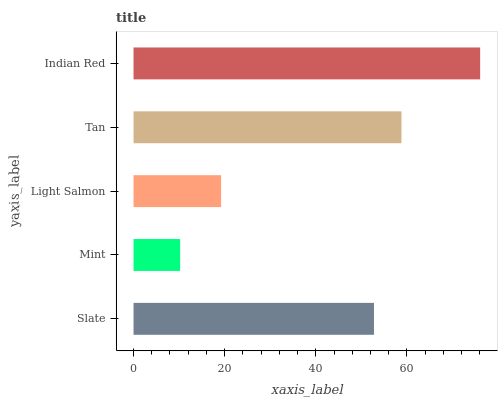Is Mint the minimum?
Answer yes or no. Yes. Is Indian Red the maximum?
Answer yes or no. Yes. Is Light Salmon the minimum?
Answer yes or no. No. Is Light Salmon the maximum?
Answer yes or no. No. Is Light Salmon greater than Mint?
Answer yes or no. Yes. Is Mint less than Light Salmon?
Answer yes or no. Yes. Is Mint greater than Light Salmon?
Answer yes or no. No. Is Light Salmon less than Mint?
Answer yes or no. No. Is Slate the high median?
Answer yes or no. Yes. Is Slate the low median?
Answer yes or no. Yes. Is Indian Red the high median?
Answer yes or no. No. Is Tan the low median?
Answer yes or no. No. 